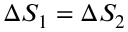Convert formula to latex. <formula><loc_0><loc_0><loc_500><loc_500>\Delta S _ { 1 } = \Delta S _ { 2 }</formula> 